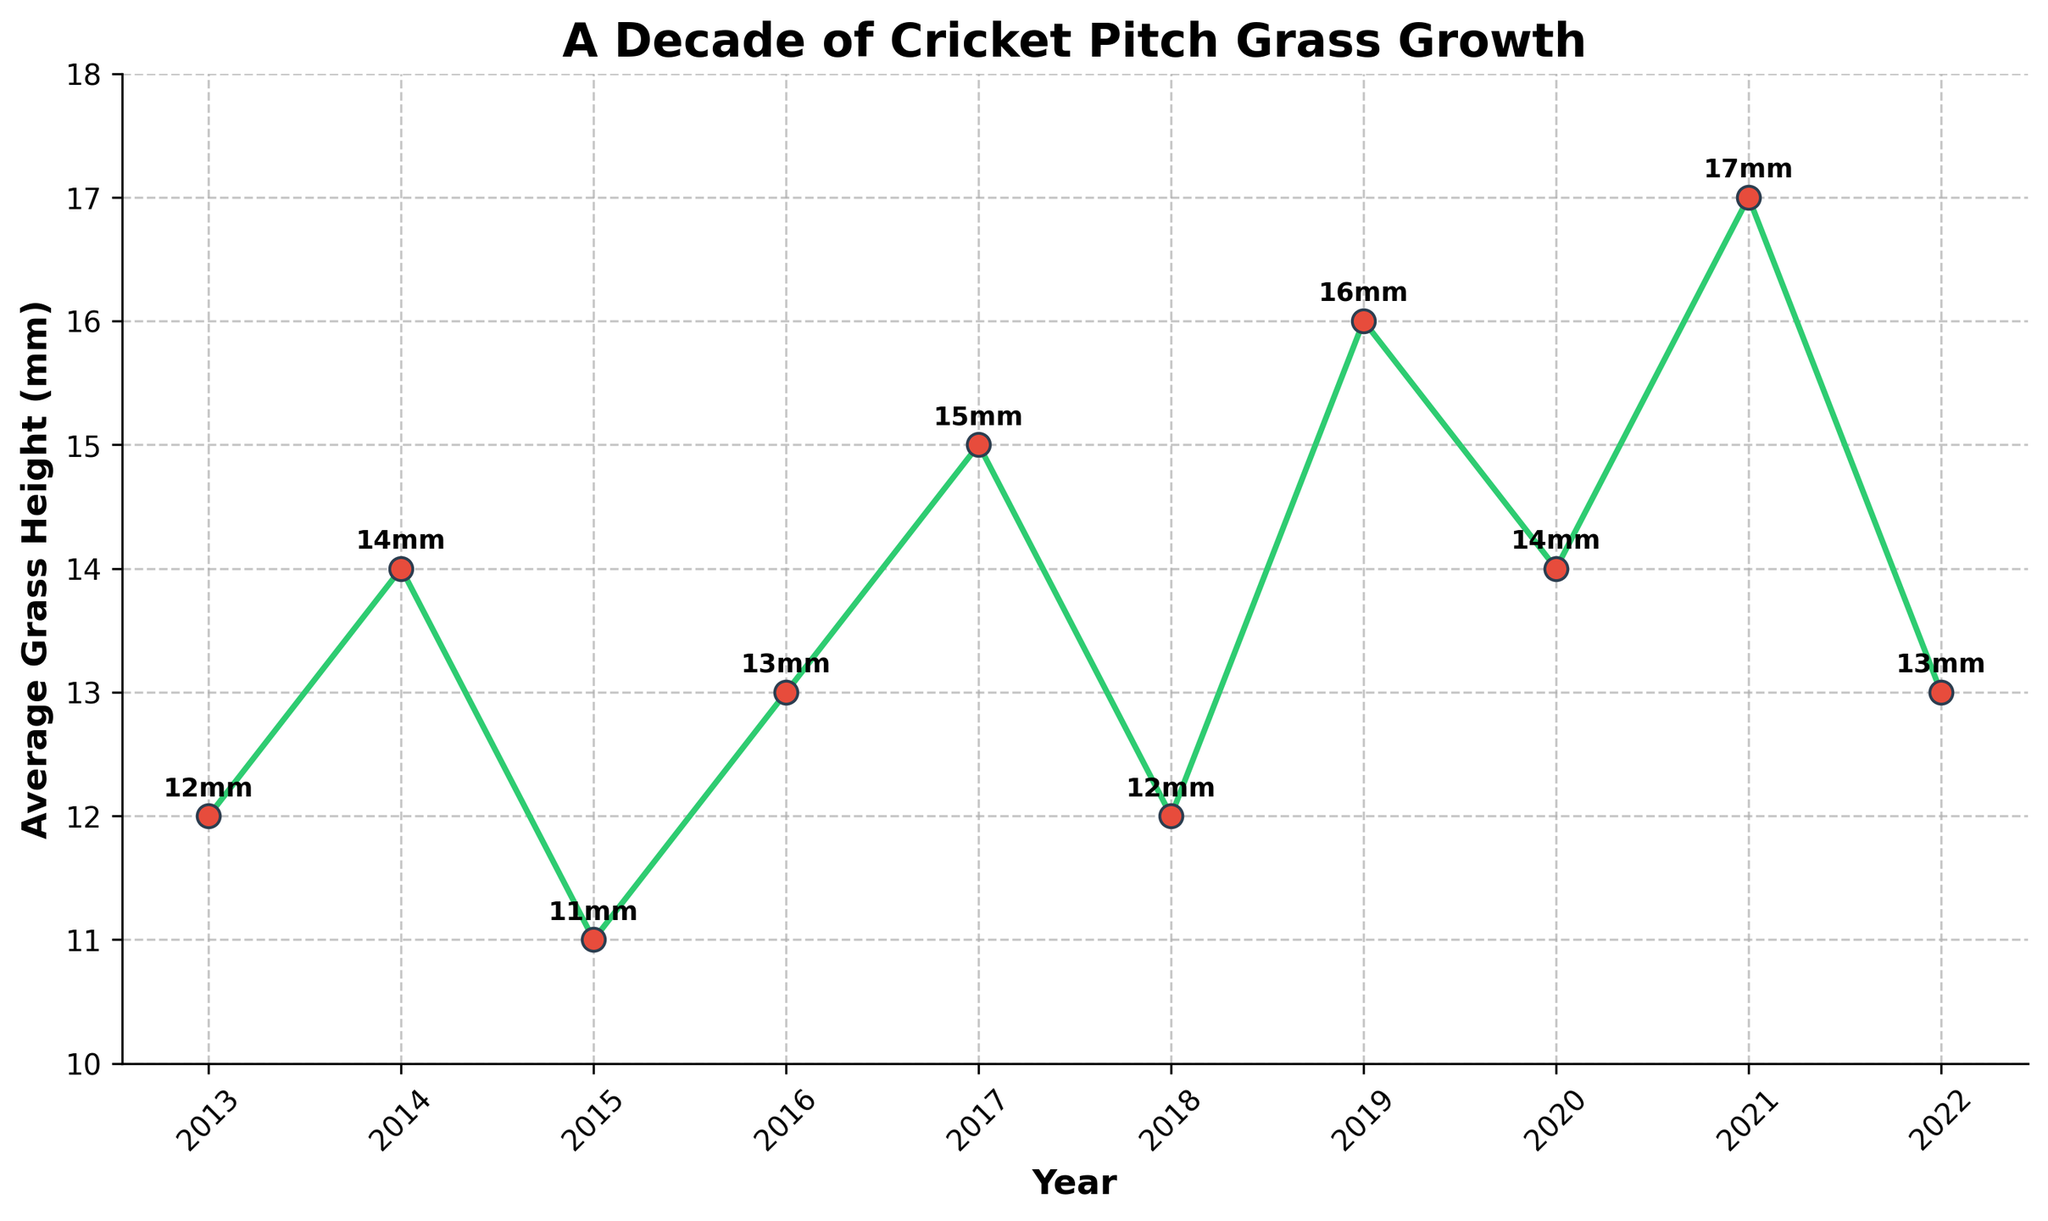What's the average grass height over the decade? To calculate the average grass height over the decade, sum all the yearly heights and then divide by the number of years. (12 + 14 + 11 + 13 + 15 + 12 + 16 + 14 + 17 + 13) / 10 = 137 / 10 = 13.7 mm
Answer: 13.7 mm Which year had the tallest grass height? Identify the year with the highest vertical point on the chart. The highest point is in 2021 with an average grass height of 17mm.
Answer: 2021 Which years had the same average grass height? Look for points on the chart with the same height value. Both 2018 and 2022 have an average grass height of 13mm, and 2018 and 2014 had an average grass height of 14mm.
Answer: 2014 and 2020 What is the difference in grass height between the year with the highest and the lowest values? Determine the highest and lowest values from the chart, which are 17mm in 2021 and 11mm in 2015. The difference is 17mm - 11mm = 6mm.
Answer: 6mm During which period did the grass height decrease the most? Examine the slopes of the lines between consecutive years. The steepest downward slope is between 2017 and 2018, where it decreased from 15mm to 12mm, a difference of 3mm.
Answer: 2017-2018 In which year was the increase in grass height the most significant? Look at the upward slopes of the line chart and identify the year-to-year change. The largest increase is from 2018 to 2019, where it went from 12mm to 16mm, a difference of 4mm.
Answer: 2018-2019 What's the average grass height from 2016 to 2019? Sum the grass heights from 2016 to 2019 and divide by the number of years: (13 + 15 + 12 + 16) / 4 = 56 / 4 = 14mm.
Answer: 14 mm Was the grass height higher on average in the first half of the decade or the second half? Sum the grass heights for 2013-2017 and 2018-2022, and divide by 5 respectively. First half: (12 + 14 + 11 + 13 + 15) / 5 = 65 / 5 = 13mm; Second half: (12 + 16 + 14 + 17 + 13) / 5 = 72 / 5 = 14.4mm.
Answer: Second half Which year experienced the lowest grass height? Identify the lowest point on the chart. The lowest point is in 2015 with an average grass height of 11mm.
Answer: 2015 